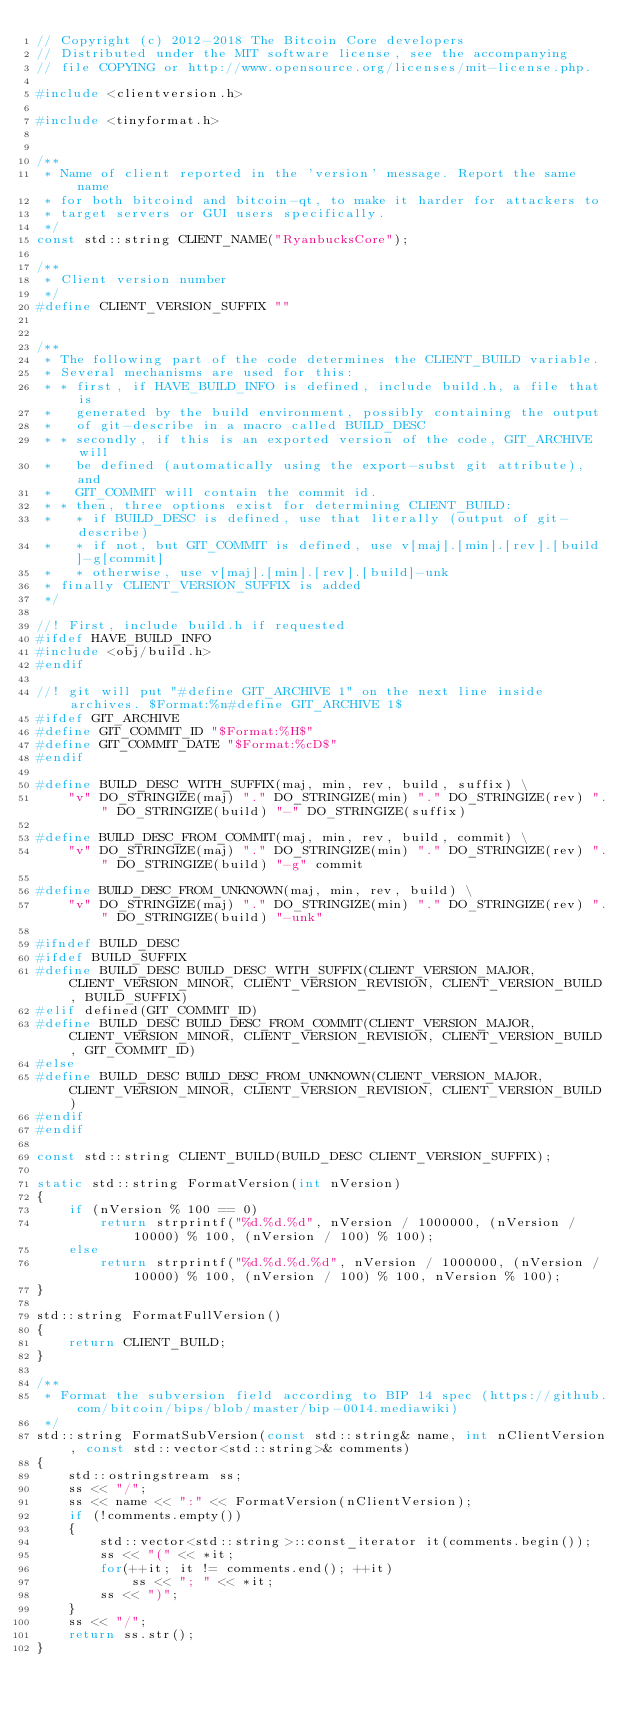Convert code to text. <code><loc_0><loc_0><loc_500><loc_500><_C++_>// Copyright (c) 2012-2018 The Bitcoin Core developers
// Distributed under the MIT software license, see the accompanying
// file COPYING or http://www.opensource.org/licenses/mit-license.php.

#include <clientversion.h>

#include <tinyformat.h>


/**
 * Name of client reported in the 'version' message. Report the same name
 * for both bitcoind and bitcoin-qt, to make it harder for attackers to
 * target servers or GUI users specifically.
 */
const std::string CLIENT_NAME("RyanbucksCore");

/**
 * Client version number
 */
#define CLIENT_VERSION_SUFFIX ""


/**
 * The following part of the code determines the CLIENT_BUILD variable.
 * Several mechanisms are used for this:
 * * first, if HAVE_BUILD_INFO is defined, include build.h, a file that is
 *   generated by the build environment, possibly containing the output
 *   of git-describe in a macro called BUILD_DESC
 * * secondly, if this is an exported version of the code, GIT_ARCHIVE will
 *   be defined (automatically using the export-subst git attribute), and
 *   GIT_COMMIT will contain the commit id.
 * * then, three options exist for determining CLIENT_BUILD:
 *   * if BUILD_DESC is defined, use that literally (output of git-describe)
 *   * if not, but GIT_COMMIT is defined, use v[maj].[min].[rev].[build]-g[commit]
 *   * otherwise, use v[maj].[min].[rev].[build]-unk
 * finally CLIENT_VERSION_SUFFIX is added
 */

//! First, include build.h if requested
#ifdef HAVE_BUILD_INFO
#include <obj/build.h>
#endif

//! git will put "#define GIT_ARCHIVE 1" on the next line inside archives. $Format:%n#define GIT_ARCHIVE 1$
#ifdef GIT_ARCHIVE
#define GIT_COMMIT_ID "$Format:%H$"
#define GIT_COMMIT_DATE "$Format:%cD$"
#endif

#define BUILD_DESC_WITH_SUFFIX(maj, min, rev, build, suffix) \
    "v" DO_STRINGIZE(maj) "." DO_STRINGIZE(min) "." DO_STRINGIZE(rev) "." DO_STRINGIZE(build) "-" DO_STRINGIZE(suffix)

#define BUILD_DESC_FROM_COMMIT(maj, min, rev, build, commit) \
    "v" DO_STRINGIZE(maj) "." DO_STRINGIZE(min) "." DO_STRINGIZE(rev) "." DO_STRINGIZE(build) "-g" commit

#define BUILD_DESC_FROM_UNKNOWN(maj, min, rev, build) \
    "v" DO_STRINGIZE(maj) "." DO_STRINGIZE(min) "." DO_STRINGIZE(rev) "." DO_STRINGIZE(build) "-unk"

#ifndef BUILD_DESC
#ifdef BUILD_SUFFIX
#define BUILD_DESC BUILD_DESC_WITH_SUFFIX(CLIENT_VERSION_MAJOR, CLIENT_VERSION_MINOR, CLIENT_VERSION_REVISION, CLIENT_VERSION_BUILD, BUILD_SUFFIX)
#elif defined(GIT_COMMIT_ID)
#define BUILD_DESC BUILD_DESC_FROM_COMMIT(CLIENT_VERSION_MAJOR, CLIENT_VERSION_MINOR, CLIENT_VERSION_REVISION, CLIENT_VERSION_BUILD, GIT_COMMIT_ID)
#else
#define BUILD_DESC BUILD_DESC_FROM_UNKNOWN(CLIENT_VERSION_MAJOR, CLIENT_VERSION_MINOR, CLIENT_VERSION_REVISION, CLIENT_VERSION_BUILD)
#endif
#endif

const std::string CLIENT_BUILD(BUILD_DESC CLIENT_VERSION_SUFFIX);

static std::string FormatVersion(int nVersion)
{
    if (nVersion % 100 == 0)
        return strprintf("%d.%d.%d", nVersion / 1000000, (nVersion / 10000) % 100, (nVersion / 100) % 100);
    else
        return strprintf("%d.%d.%d.%d", nVersion / 1000000, (nVersion / 10000) % 100, (nVersion / 100) % 100, nVersion % 100);
}

std::string FormatFullVersion()
{
    return CLIENT_BUILD;
}

/**
 * Format the subversion field according to BIP 14 spec (https://github.com/bitcoin/bips/blob/master/bip-0014.mediawiki)
 */
std::string FormatSubVersion(const std::string& name, int nClientVersion, const std::vector<std::string>& comments)
{
    std::ostringstream ss;
    ss << "/";
    ss << name << ":" << FormatVersion(nClientVersion);
    if (!comments.empty())
    {
        std::vector<std::string>::const_iterator it(comments.begin());
        ss << "(" << *it;
        for(++it; it != comments.end(); ++it)
            ss << "; " << *it;
        ss << ")";
    }
    ss << "/";
    return ss.str();
}
</code> 